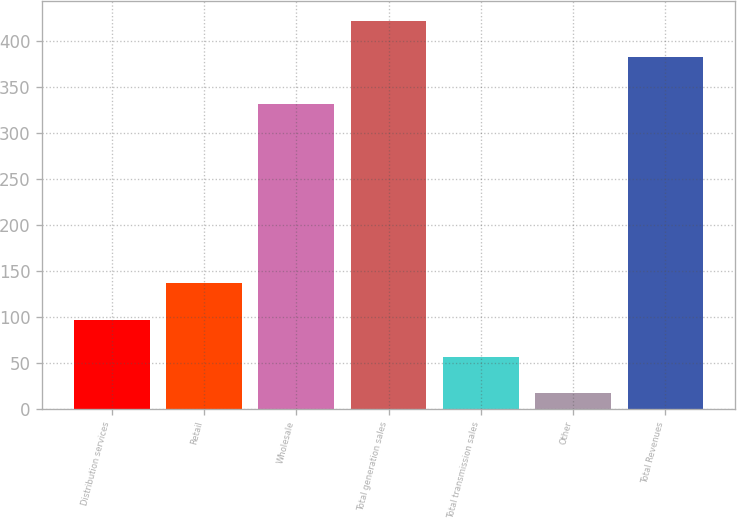Convert chart. <chart><loc_0><loc_0><loc_500><loc_500><bar_chart><fcel>Distribution services<fcel>Retail<fcel>Wholesale<fcel>Total generation sales<fcel>Total transmission sales<fcel>Other<fcel>Total Revenues<nl><fcel>96.6<fcel>136.4<fcel>331<fcel>421.8<fcel>56.8<fcel>17<fcel>382<nl></chart> 